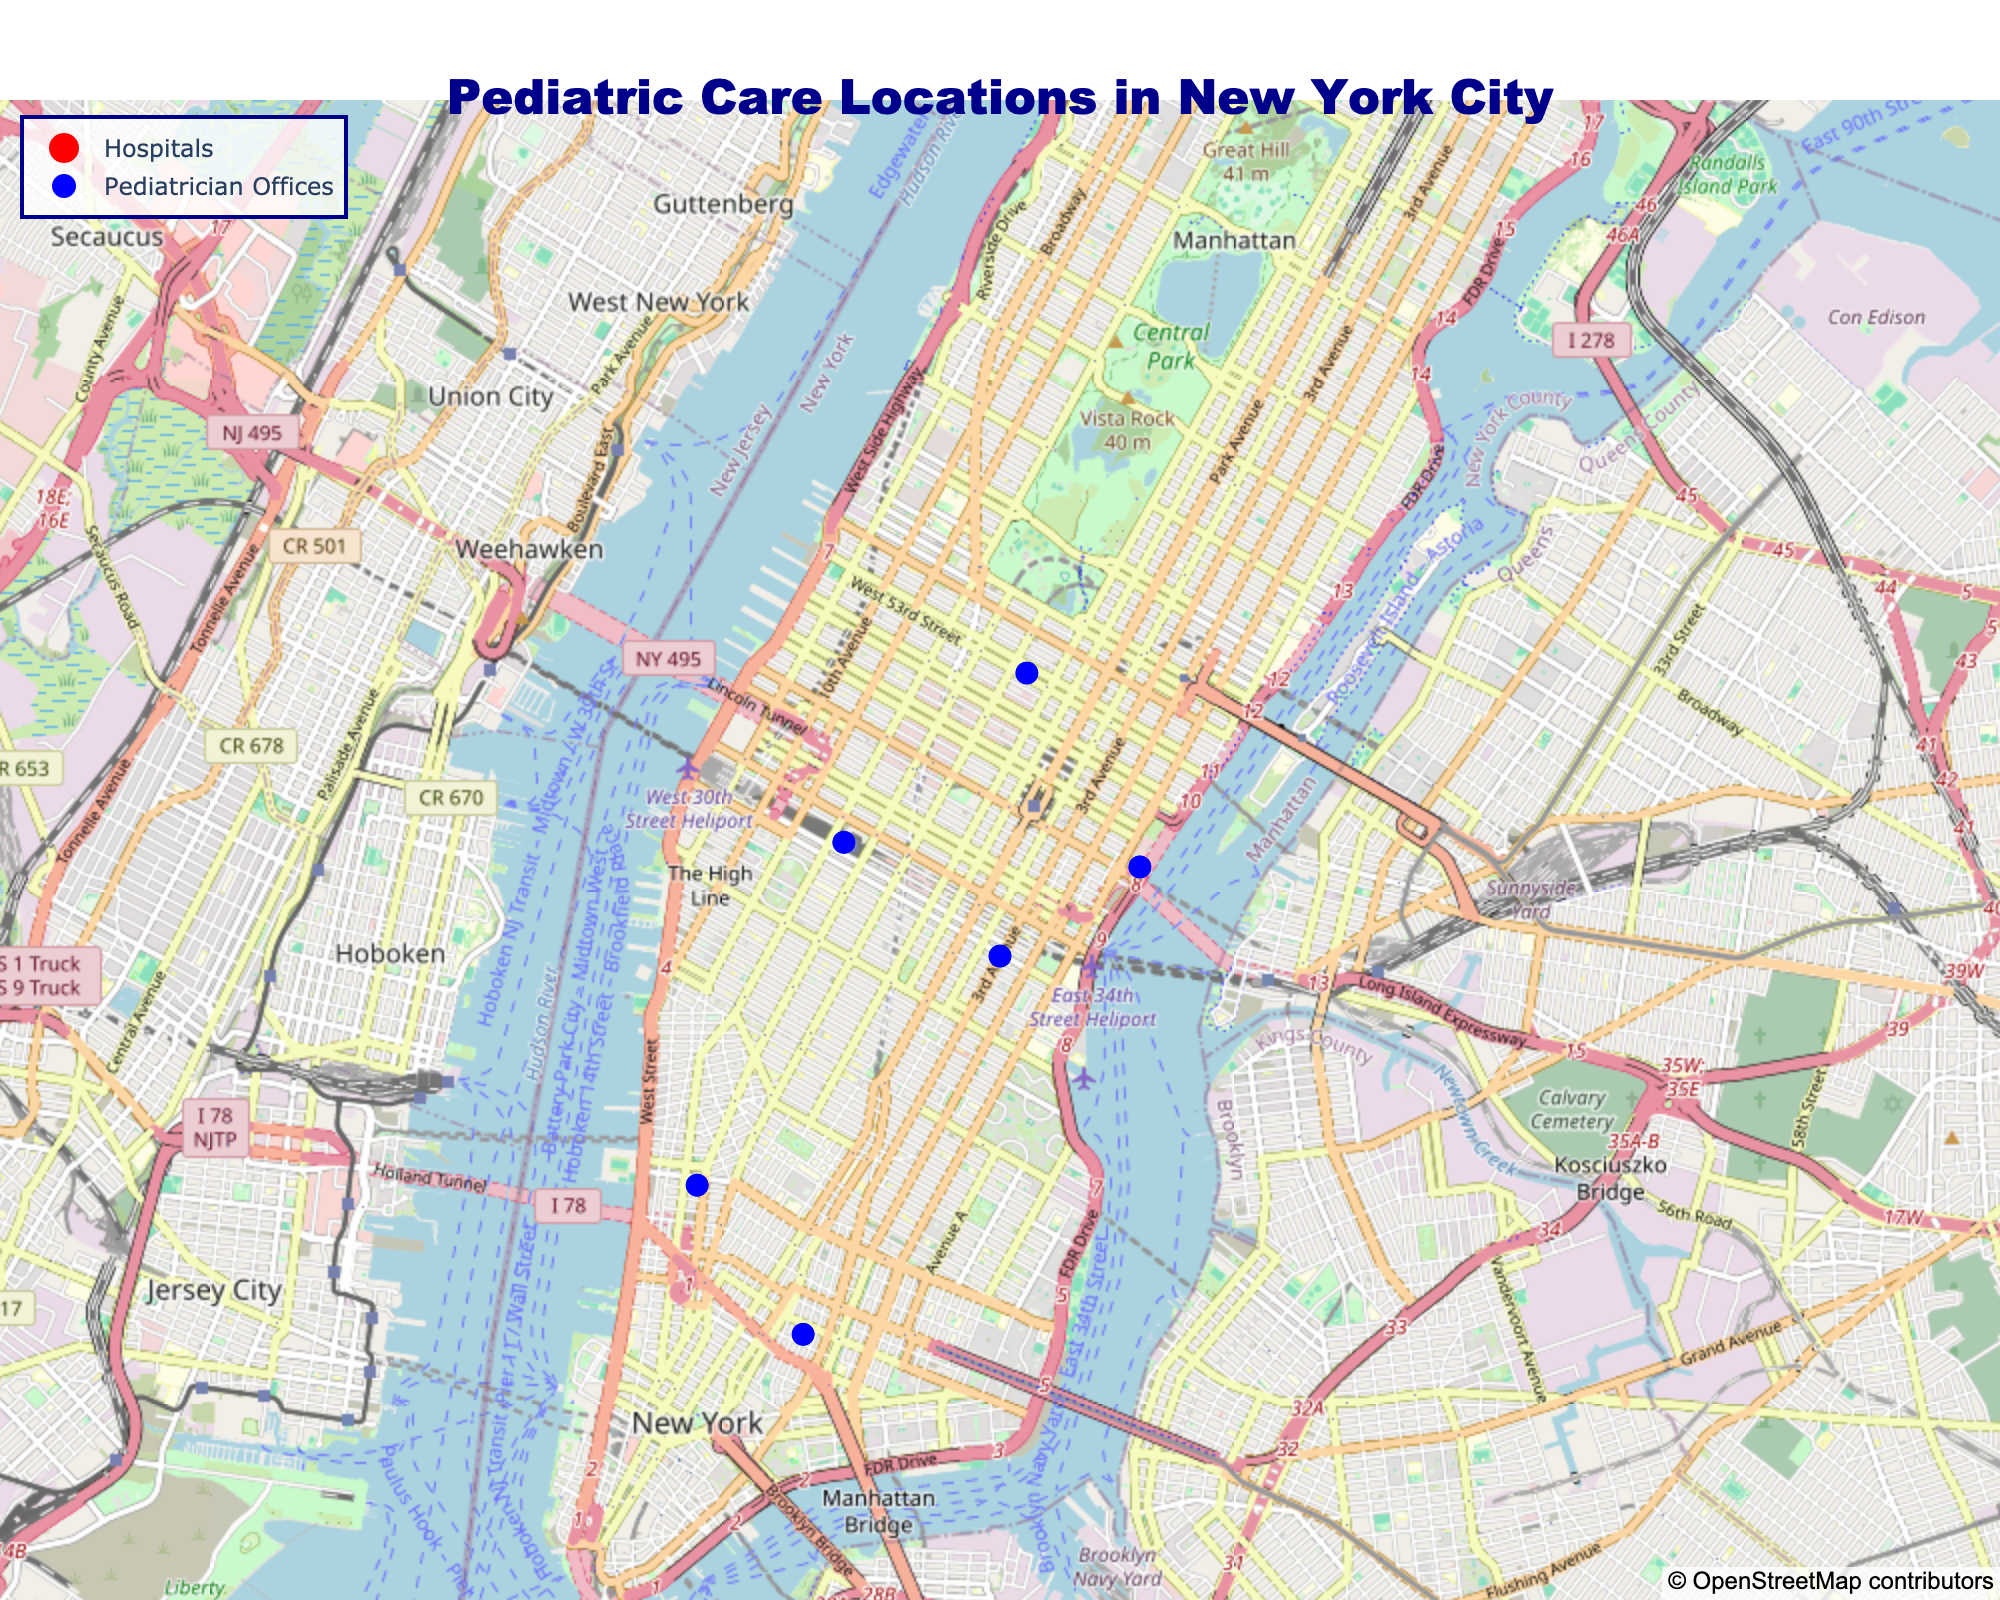What is the title of the map? The title is usually located at the top of the map and is styled in large, bold text.
Answer: Pediatric Care Locations in New York City What color and symbol are used to represent pediatrician offices? By looking at the markers for pediatrician offices on the map, we can see they are blue circles.
Answer: Blue color and circle symbol Which pediatrician office has the shortest wait time, and what is it? To find this, we look at the pediatrician offices on the map and check their wait times. The shortest wait time is indicated by the office with the smallest number in the hover text.
Answer: Little Sprouts Pediatric Care, 15 mins What is the difference in wait time between the hospital with the longest wait and the one with the shortest wait time? First, identify the hospital with the longest wait time (Bellevue Hospital Center, 60 mins) and the one with the shortest wait time (Lenox Hill Hospital, 30 mins). Then, calculate the difference: 60 mins - 30 mins = 30 mins.
Answer: 30 mins How many pediatric care locations are shown on the map? Count the total number of markers (red and blue) on the map to get the total number of pediatric care locations.
Answer: 10 Which hospital specializes in Pediatric Emergency? Hover over the red markers representing hospitals and find the one with "Pediatric Emergency" in the specialty field.
Answer: NewYork-Presbyterian Lower Manhattan Hospital Which pediatrician office is located closest to Downtown Manhattan? Downtown Manhattan's coordinates are approximately (40.7128, -74.0060). Identify the office near this coordinate by comparing the latitude and longitude values.
Answer: Dr. Smith Pediatrics How does the median wait time of pediatrician offices compare to the median wait time of hospitals? List out the wait times of pediatrician offices (20, 25, 15, 35, 30, 40) and hospitals (45, 60, 30, 40). Find the median of both groups. For offices: (20+25+15+35+30+40)/6 = 165/6 ≈ 27.5. For hospitals: (45+60+30+40)/4 = 175/4 = 43.75.
Answer: Pediatrician offices: 27.5 mins, Hospitals: 43.75 mins Which pediatrician office specializes in Pediatric Endocrinology? Hover over the blue markers representing pediatrician offices and find the one with "Pediatric Endocrinology" in the specialty field.
Answer: East Side Pediatric Group What is the average wait time across all pediatric care locations on the map? Add up all the wait times and divide by the total number of locations. (45+60+30+40+20+25+15+35+30+40) = 340. There are 10 locations. 340/10 = 34
Answer: 34 mins Which pediatric care location has the same longitude as the NewYork-Presbyterian Lower Manhattan Hospital? NewYork-Presbyterian Lower Manhattan Hospital is located at longitude -74.0060. Find the location with the same longitude.
Answer: Downtown Pediatric Associates 